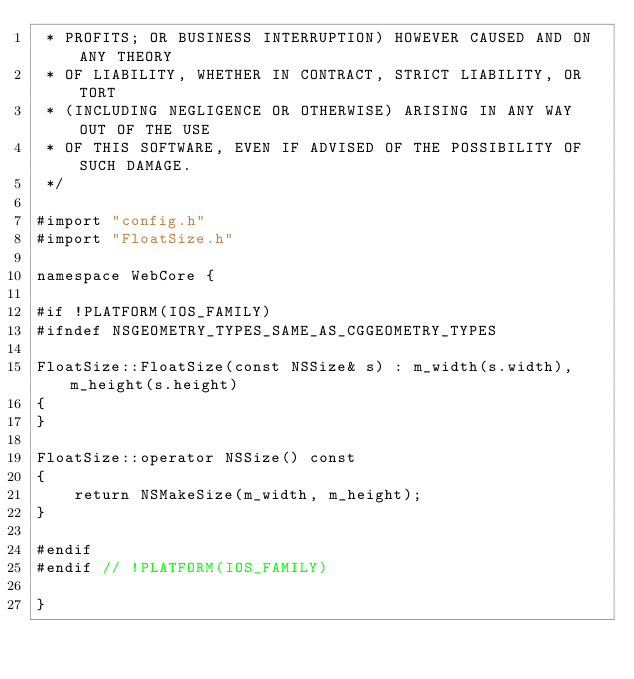Convert code to text. <code><loc_0><loc_0><loc_500><loc_500><_ObjectiveC_> * PROFITS; OR BUSINESS INTERRUPTION) HOWEVER CAUSED AND ON ANY THEORY
 * OF LIABILITY, WHETHER IN CONTRACT, STRICT LIABILITY, OR TORT
 * (INCLUDING NEGLIGENCE OR OTHERWISE) ARISING IN ANY WAY OUT OF THE USE
 * OF THIS SOFTWARE, EVEN IF ADVISED OF THE POSSIBILITY OF SUCH DAMAGE. 
 */
 
#import "config.h"
#import "FloatSize.h"

namespace WebCore {

#if !PLATFORM(IOS_FAMILY)
#ifndef NSGEOMETRY_TYPES_SAME_AS_CGGEOMETRY_TYPES

FloatSize::FloatSize(const NSSize& s) : m_width(s.width), m_height(s.height)
{
}

FloatSize::operator NSSize() const
{
    return NSMakeSize(m_width, m_height);
}

#endif
#endif // !PLATFORM(IOS_FAMILY)

}
</code> 